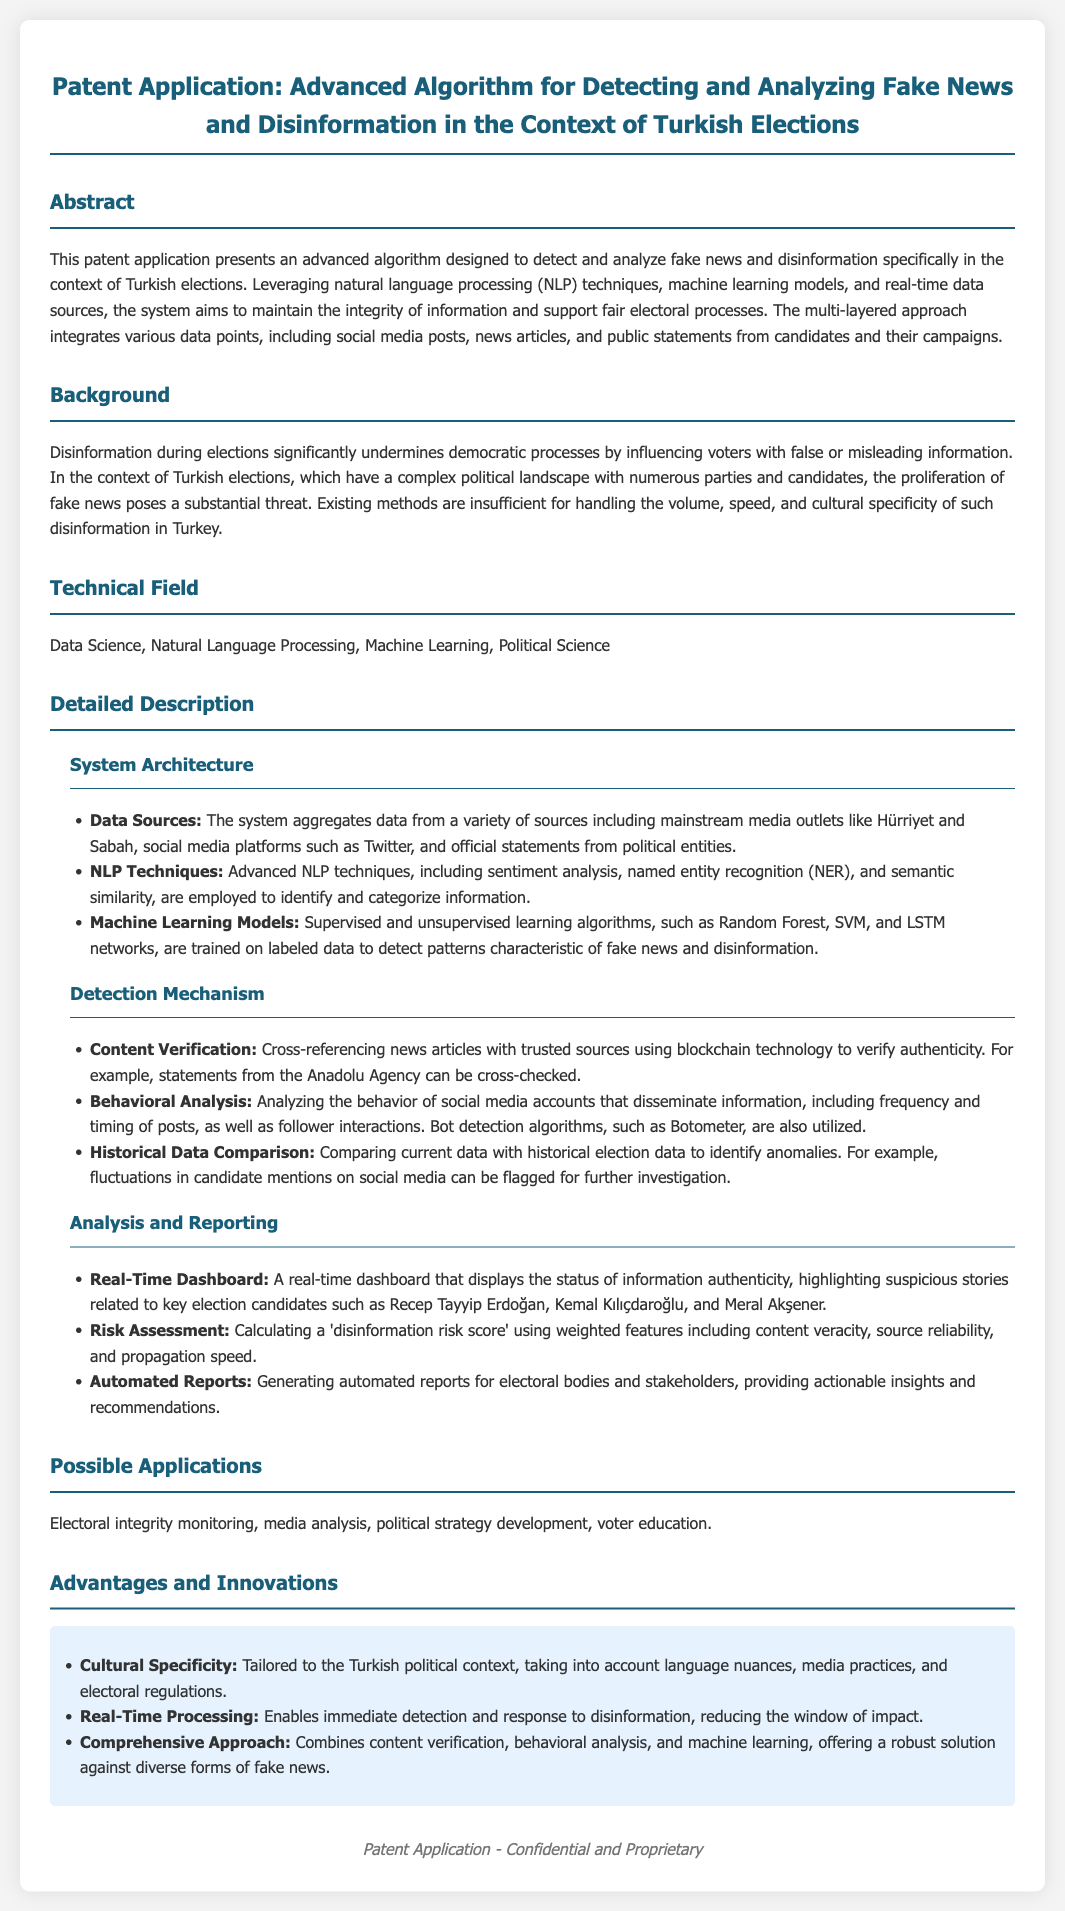What is the title of the patent application? The title of the patent application is stated at the top of the document.
Answer: Advanced Algorithm for Detecting and Analyzing Fake News and Disinformation in the Context of Turkish Elections What is the technical field of the patent? The technical field is specified in a dedicated section of the document.
Answer: Data Science, Natural Language Processing, Machine Learning, Political Science Which candidates are highlighted in the real-time dashboard? The candidates referenced are specifically mentioned in the analysis and reporting section.
Answer: Recep Tayyip Erdoğan, Kemal Kılıçdaroğlu, Meral Akşener What technology is used for content verification? The document outlines the technology used for verification in the detection mechanism section.
Answer: Blockchain technology What is one advantage of the advanced algorithm? The advantages are listed under a specific section that details the innovations of the algorithm.
Answer: Cultural Specificity Which data sources are integrated into the system? The data sources are mentioned in the system architecture subsection.
Answer: Mainstream media outlets, social media platforms, official statements How does the system analyze social media behavior? The behavioral analysis strategy is briefly explained in the detection mechanism section.
Answer: Frequency and timing of posts, follower interactions What is the purpose of the disinformation risk score? The purpose of the risk score is explained in the analysis and reporting section.
Answer: To calculate disinformation risk 